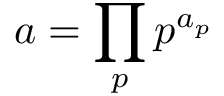<formula> <loc_0><loc_0><loc_500><loc_500>\, a = \prod _ { p } p ^ { a _ { p } }</formula> 